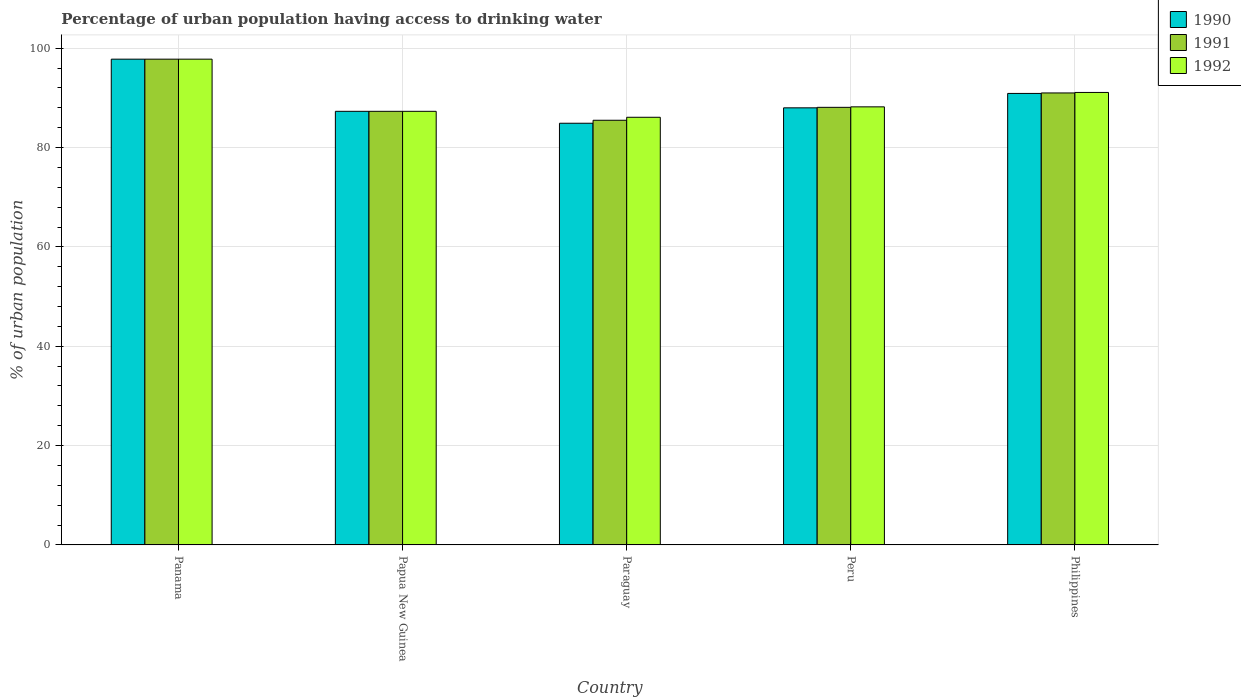How many groups of bars are there?
Offer a very short reply. 5. Are the number of bars per tick equal to the number of legend labels?
Your response must be concise. Yes. Are the number of bars on each tick of the X-axis equal?
Provide a succinct answer. Yes. How many bars are there on the 5th tick from the left?
Provide a short and direct response. 3. How many bars are there on the 3rd tick from the right?
Offer a very short reply. 3. What is the label of the 1st group of bars from the left?
Offer a terse response. Panama. What is the percentage of urban population having access to drinking water in 1990 in Peru?
Make the answer very short. 88. Across all countries, what is the maximum percentage of urban population having access to drinking water in 1992?
Offer a very short reply. 97.8. Across all countries, what is the minimum percentage of urban population having access to drinking water in 1991?
Keep it short and to the point. 85.5. In which country was the percentage of urban population having access to drinking water in 1991 maximum?
Make the answer very short. Panama. In which country was the percentage of urban population having access to drinking water in 1991 minimum?
Your response must be concise. Paraguay. What is the total percentage of urban population having access to drinking water in 1991 in the graph?
Keep it short and to the point. 449.7. What is the difference between the percentage of urban population having access to drinking water in 1990 in Papua New Guinea and that in Paraguay?
Make the answer very short. 2.4. What is the difference between the percentage of urban population having access to drinking water in 1990 in Papua New Guinea and the percentage of urban population having access to drinking water in 1992 in Philippines?
Make the answer very short. -3.8. What is the average percentage of urban population having access to drinking water in 1990 per country?
Keep it short and to the point. 89.78. What is the ratio of the percentage of urban population having access to drinking water in 1991 in Paraguay to that in Peru?
Ensure brevity in your answer.  0.97. Is the percentage of urban population having access to drinking water in 1992 in Panama less than that in Paraguay?
Provide a short and direct response. No. What is the difference between the highest and the second highest percentage of urban population having access to drinking water in 1990?
Provide a succinct answer. -9.8. What is the difference between the highest and the lowest percentage of urban population having access to drinking water in 1992?
Your response must be concise. 11.7. Is the sum of the percentage of urban population having access to drinking water in 1991 in Peru and Philippines greater than the maximum percentage of urban population having access to drinking water in 1990 across all countries?
Give a very brief answer. Yes. Is it the case that in every country, the sum of the percentage of urban population having access to drinking water in 1991 and percentage of urban population having access to drinking water in 1992 is greater than the percentage of urban population having access to drinking water in 1990?
Your answer should be compact. Yes. Are all the bars in the graph horizontal?
Your response must be concise. No. What is the difference between two consecutive major ticks on the Y-axis?
Your response must be concise. 20. Does the graph contain any zero values?
Provide a succinct answer. No. Does the graph contain grids?
Give a very brief answer. Yes. How many legend labels are there?
Offer a terse response. 3. How are the legend labels stacked?
Provide a short and direct response. Vertical. What is the title of the graph?
Provide a succinct answer. Percentage of urban population having access to drinking water. What is the label or title of the X-axis?
Make the answer very short. Country. What is the label or title of the Y-axis?
Your response must be concise. % of urban population. What is the % of urban population of 1990 in Panama?
Your response must be concise. 97.8. What is the % of urban population of 1991 in Panama?
Your answer should be very brief. 97.8. What is the % of urban population in 1992 in Panama?
Make the answer very short. 97.8. What is the % of urban population of 1990 in Papua New Guinea?
Ensure brevity in your answer.  87.3. What is the % of urban population of 1991 in Papua New Guinea?
Offer a very short reply. 87.3. What is the % of urban population of 1992 in Papua New Guinea?
Give a very brief answer. 87.3. What is the % of urban population of 1990 in Paraguay?
Keep it short and to the point. 84.9. What is the % of urban population in 1991 in Paraguay?
Offer a very short reply. 85.5. What is the % of urban population in 1992 in Paraguay?
Offer a terse response. 86.1. What is the % of urban population in 1990 in Peru?
Your response must be concise. 88. What is the % of urban population of 1991 in Peru?
Offer a terse response. 88.1. What is the % of urban population in 1992 in Peru?
Ensure brevity in your answer.  88.2. What is the % of urban population in 1990 in Philippines?
Ensure brevity in your answer.  90.9. What is the % of urban population of 1991 in Philippines?
Offer a terse response. 91. What is the % of urban population of 1992 in Philippines?
Provide a succinct answer. 91.1. Across all countries, what is the maximum % of urban population of 1990?
Make the answer very short. 97.8. Across all countries, what is the maximum % of urban population in 1991?
Provide a short and direct response. 97.8. Across all countries, what is the maximum % of urban population in 1992?
Your response must be concise. 97.8. Across all countries, what is the minimum % of urban population in 1990?
Keep it short and to the point. 84.9. Across all countries, what is the minimum % of urban population in 1991?
Ensure brevity in your answer.  85.5. Across all countries, what is the minimum % of urban population of 1992?
Your answer should be compact. 86.1. What is the total % of urban population of 1990 in the graph?
Offer a very short reply. 448.9. What is the total % of urban population of 1991 in the graph?
Make the answer very short. 449.7. What is the total % of urban population in 1992 in the graph?
Offer a very short reply. 450.5. What is the difference between the % of urban population in 1991 in Panama and that in Papua New Guinea?
Make the answer very short. 10.5. What is the difference between the % of urban population in 1992 in Panama and that in Papua New Guinea?
Offer a terse response. 10.5. What is the difference between the % of urban population of 1990 in Panama and that in Paraguay?
Ensure brevity in your answer.  12.9. What is the difference between the % of urban population in 1991 in Panama and that in Paraguay?
Make the answer very short. 12.3. What is the difference between the % of urban population of 1992 in Panama and that in Paraguay?
Your answer should be compact. 11.7. What is the difference between the % of urban population of 1991 in Panama and that in Peru?
Make the answer very short. 9.7. What is the difference between the % of urban population in 1990 in Panama and that in Philippines?
Offer a very short reply. 6.9. What is the difference between the % of urban population in 1991 in Panama and that in Philippines?
Offer a terse response. 6.8. What is the difference between the % of urban population of 1992 in Panama and that in Philippines?
Your answer should be compact. 6.7. What is the difference between the % of urban population of 1990 in Papua New Guinea and that in Paraguay?
Keep it short and to the point. 2.4. What is the difference between the % of urban population in 1991 in Papua New Guinea and that in Paraguay?
Provide a succinct answer. 1.8. What is the difference between the % of urban population in 1992 in Papua New Guinea and that in Peru?
Your answer should be compact. -0.9. What is the difference between the % of urban population of 1992 in Papua New Guinea and that in Philippines?
Your answer should be compact. -3.8. What is the difference between the % of urban population in 1990 in Paraguay and that in Peru?
Offer a terse response. -3.1. What is the difference between the % of urban population of 1991 in Paraguay and that in Peru?
Your response must be concise. -2.6. What is the difference between the % of urban population in 1990 in Paraguay and that in Philippines?
Offer a very short reply. -6. What is the difference between the % of urban population of 1992 in Paraguay and that in Philippines?
Make the answer very short. -5. What is the difference between the % of urban population in 1990 in Peru and that in Philippines?
Offer a terse response. -2.9. What is the difference between the % of urban population in 1990 in Panama and the % of urban population in 1992 in Papua New Guinea?
Provide a succinct answer. 10.5. What is the difference between the % of urban population in 1990 in Panama and the % of urban population in 1991 in Paraguay?
Ensure brevity in your answer.  12.3. What is the difference between the % of urban population of 1990 in Panama and the % of urban population of 1991 in Peru?
Your answer should be very brief. 9.7. What is the difference between the % of urban population in 1990 in Panama and the % of urban population in 1992 in Peru?
Provide a succinct answer. 9.6. What is the difference between the % of urban population in 1991 in Panama and the % of urban population in 1992 in Peru?
Ensure brevity in your answer.  9.6. What is the difference between the % of urban population of 1990 in Panama and the % of urban population of 1991 in Philippines?
Give a very brief answer. 6.8. What is the difference between the % of urban population of 1990 in Panama and the % of urban population of 1992 in Philippines?
Offer a very short reply. 6.7. What is the difference between the % of urban population of 1991 in Panama and the % of urban population of 1992 in Philippines?
Offer a terse response. 6.7. What is the difference between the % of urban population in 1990 in Papua New Guinea and the % of urban population in 1991 in Philippines?
Your answer should be compact. -3.7. What is the difference between the % of urban population in 1990 in Papua New Guinea and the % of urban population in 1992 in Philippines?
Keep it short and to the point. -3.8. What is the difference between the % of urban population of 1991 in Papua New Guinea and the % of urban population of 1992 in Philippines?
Offer a terse response. -3.8. What is the difference between the % of urban population of 1990 in Paraguay and the % of urban population of 1991 in Peru?
Your answer should be very brief. -3.2. What is the difference between the % of urban population of 1991 in Paraguay and the % of urban population of 1992 in Peru?
Offer a very short reply. -2.7. What is the difference between the % of urban population in 1990 in Paraguay and the % of urban population in 1992 in Philippines?
Keep it short and to the point. -6.2. What is the difference between the % of urban population in 1991 in Peru and the % of urban population in 1992 in Philippines?
Keep it short and to the point. -3. What is the average % of urban population of 1990 per country?
Provide a short and direct response. 89.78. What is the average % of urban population in 1991 per country?
Provide a succinct answer. 89.94. What is the average % of urban population of 1992 per country?
Make the answer very short. 90.1. What is the difference between the % of urban population of 1990 and % of urban population of 1991 in Panama?
Provide a succinct answer. 0. What is the difference between the % of urban population of 1990 and % of urban population of 1991 in Papua New Guinea?
Make the answer very short. 0. What is the difference between the % of urban population of 1990 and % of urban population of 1991 in Philippines?
Give a very brief answer. -0.1. What is the ratio of the % of urban population of 1990 in Panama to that in Papua New Guinea?
Ensure brevity in your answer.  1.12. What is the ratio of the % of urban population of 1991 in Panama to that in Papua New Guinea?
Offer a very short reply. 1.12. What is the ratio of the % of urban population of 1992 in Panama to that in Papua New Guinea?
Your answer should be compact. 1.12. What is the ratio of the % of urban population of 1990 in Panama to that in Paraguay?
Offer a terse response. 1.15. What is the ratio of the % of urban population in 1991 in Panama to that in Paraguay?
Ensure brevity in your answer.  1.14. What is the ratio of the % of urban population of 1992 in Panama to that in Paraguay?
Your answer should be very brief. 1.14. What is the ratio of the % of urban population in 1990 in Panama to that in Peru?
Offer a very short reply. 1.11. What is the ratio of the % of urban population of 1991 in Panama to that in Peru?
Keep it short and to the point. 1.11. What is the ratio of the % of urban population in 1992 in Panama to that in Peru?
Your answer should be very brief. 1.11. What is the ratio of the % of urban population in 1990 in Panama to that in Philippines?
Keep it short and to the point. 1.08. What is the ratio of the % of urban population of 1991 in Panama to that in Philippines?
Offer a very short reply. 1.07. What is the ratio of the % of urban population in 1992 in Panama to that in Philippines?
Make the answer very short. 1.07. What is the ratio of the % of urban population of 1990 in Papua New Guinea to that in Paraguay?
Offer a very short reply. 1.03. What is the ratio of the % of urban population of 1991 in Papua New Guinea to that in Paraguay?
Provide a short and direct response. 1.02. What is the ratio of the % of urban population in 1992 in Papua New Guinea to that in Paraguay?
Your answer should be compact. 1.01. What is the ratio of the % of urban population in 1991 in Papua New Guinea to that in Peru?
Ensure brevity in your answer.  0.99. What is the ratio of the % of urban population in 1992 in Papua New Guinea to that in Peru?
Provide a succinct answer. 0.99. What is the ratio of the % of urban population of 1990 in Papua New Guinea to that in Philippines?
Give a very brief answer. 0.96. What is the ratio of the % of urban population of 1991 in Papua New Guinea to that in Philippines?
Offer a very short reply. 0.96. What is the ratio of the % of urban population in 1990 in Paraguay to that in Peru?
Your response must be concise. 0.96. What is the ratio of the % of urban population in 1991 in Paraguay to that in Peru?
Provide a succinct answer. 0.97. What is the ratio of the % of urban population of 1992 in Paraguay to that in Peru?
Offer a terse response. 0.98. What is the ratio of the % of urban population of 1990 in Paraguay to that in Philippines?
Make the answer very short. 0.93. What is the ratio of the % of urban population in 1991 in Paraguay to that in Philippines?
Your answer should be compact. 0.94. What is the ratio of the % of urban population in 1992 in Paraguay to that in Philippines?
Your answer should be very brief. 0.95. What is the ratio of the % of urban population in 1990 in Peru to that in Philippines?
Provide a succinct answer. 0.97. What is the ratio of the % of urban population of 1991 in Peru to that in Philippines?
Provide a short and direct response. 0.97. What is the ratio of the % of urban population in 1992 in Peru to that in Philippines?
Give a very brief answer. 0.97. What is the difference between the highest and the second highest % of urban population of 1990?
Your response must be concise. 6.9. What is the difference between the highest and the second highest % of urban population of 1991?
Provide a succinct answer. 6.8. 